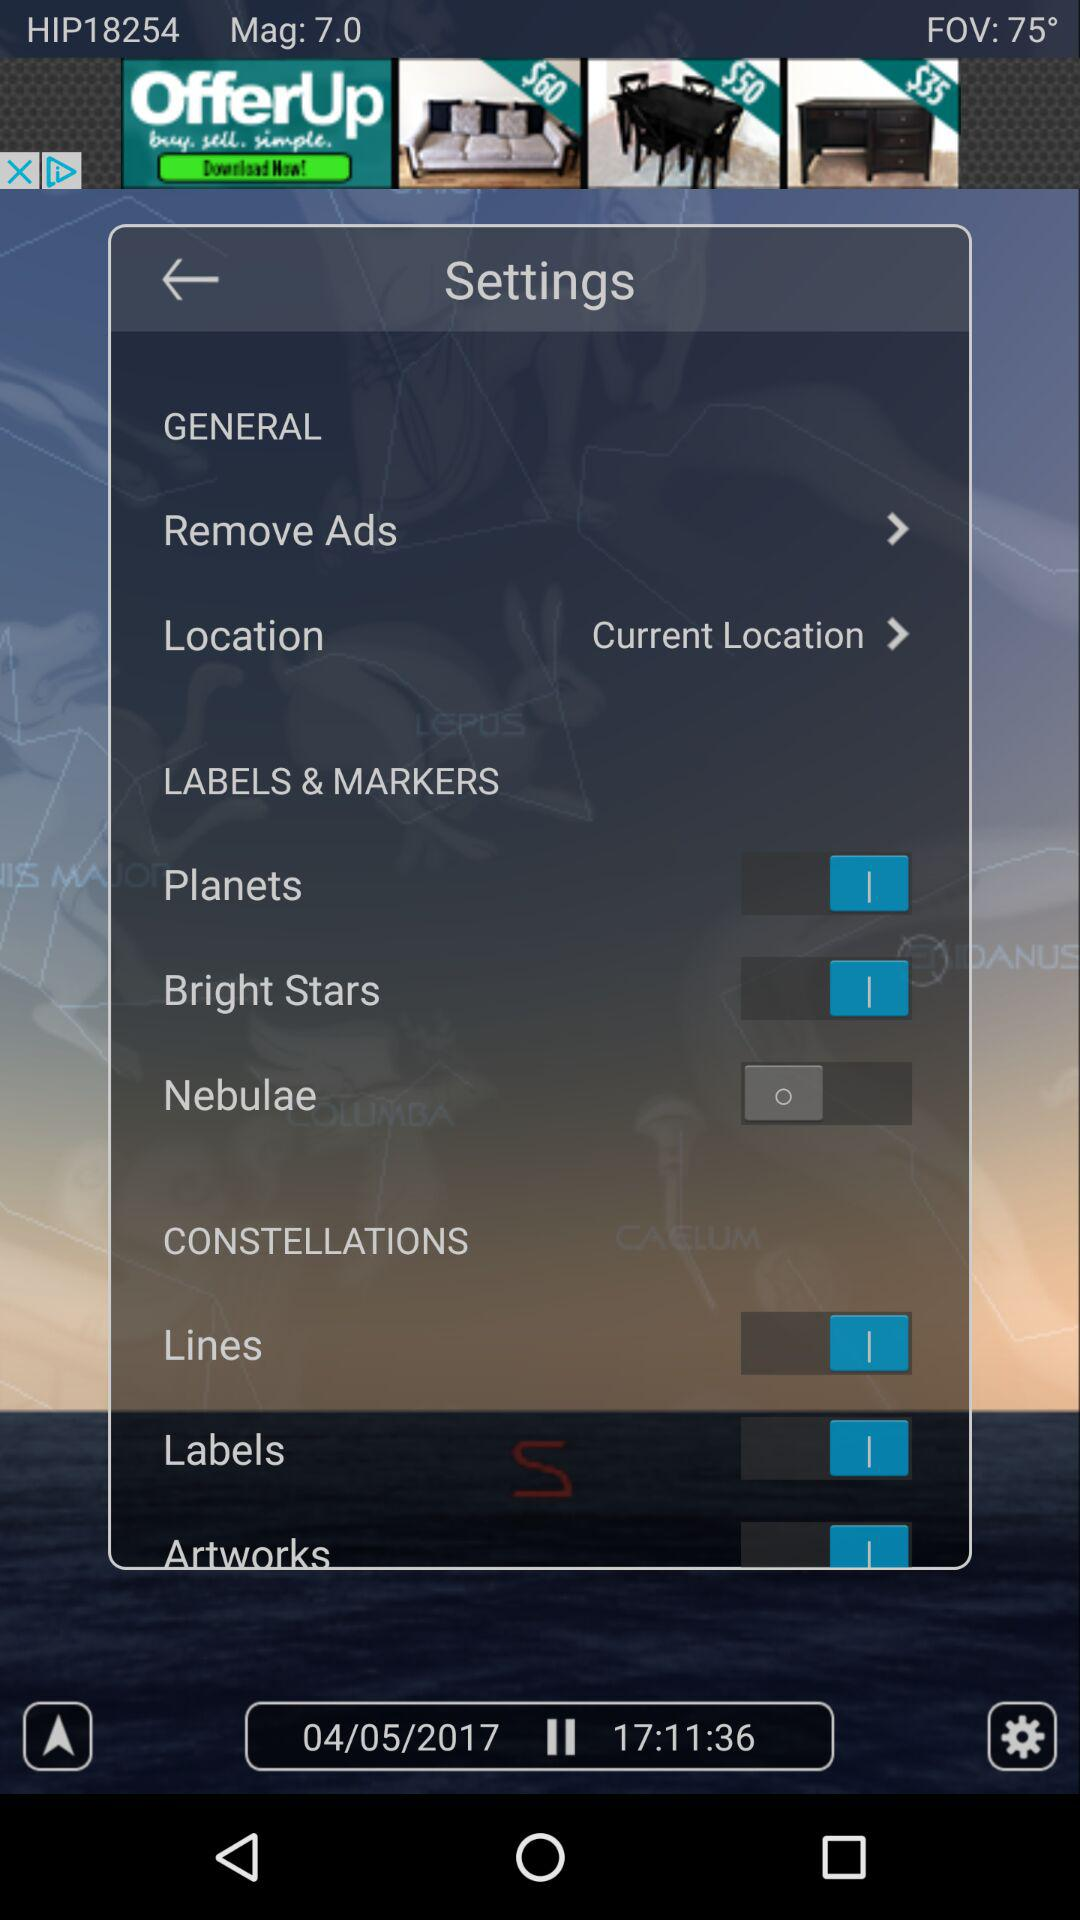What is the date and time? The date is May 4, 2017 and the time is 17:11:36. 